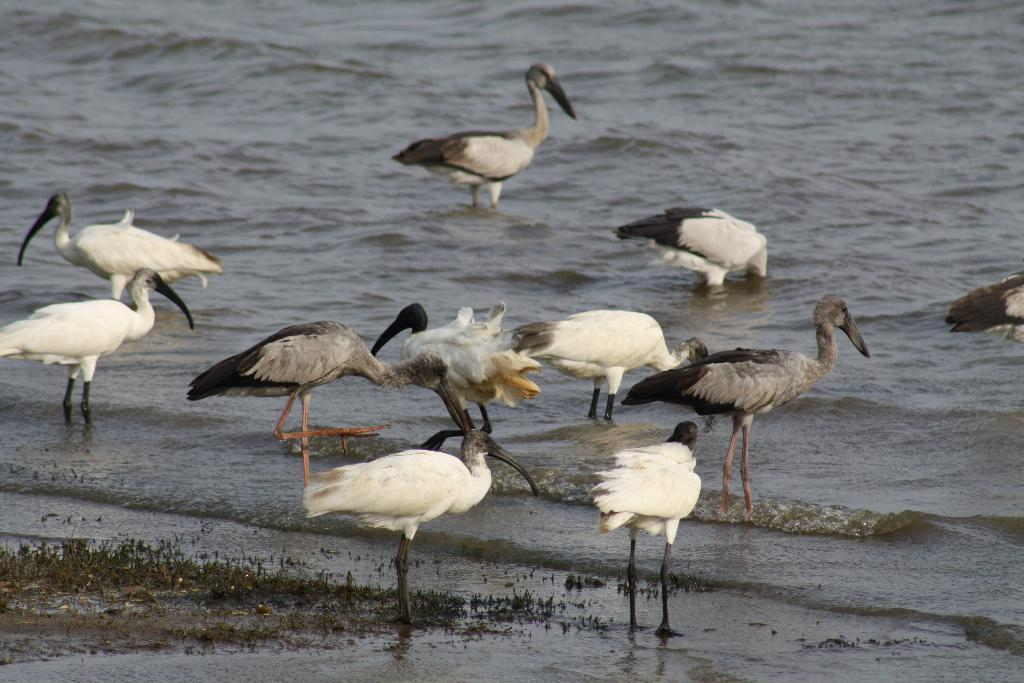What is the primary element visible in the image? There is water in the image. What types of animals can be seen in the water? There are different cranes in the water. What is located on the left side of the image? There is something on the sea shore on the left side of the image. What type of voice can be heard coming from the cranes in the image? There is no indication of sound or voice in the image, as it only shows cranes in the water. 